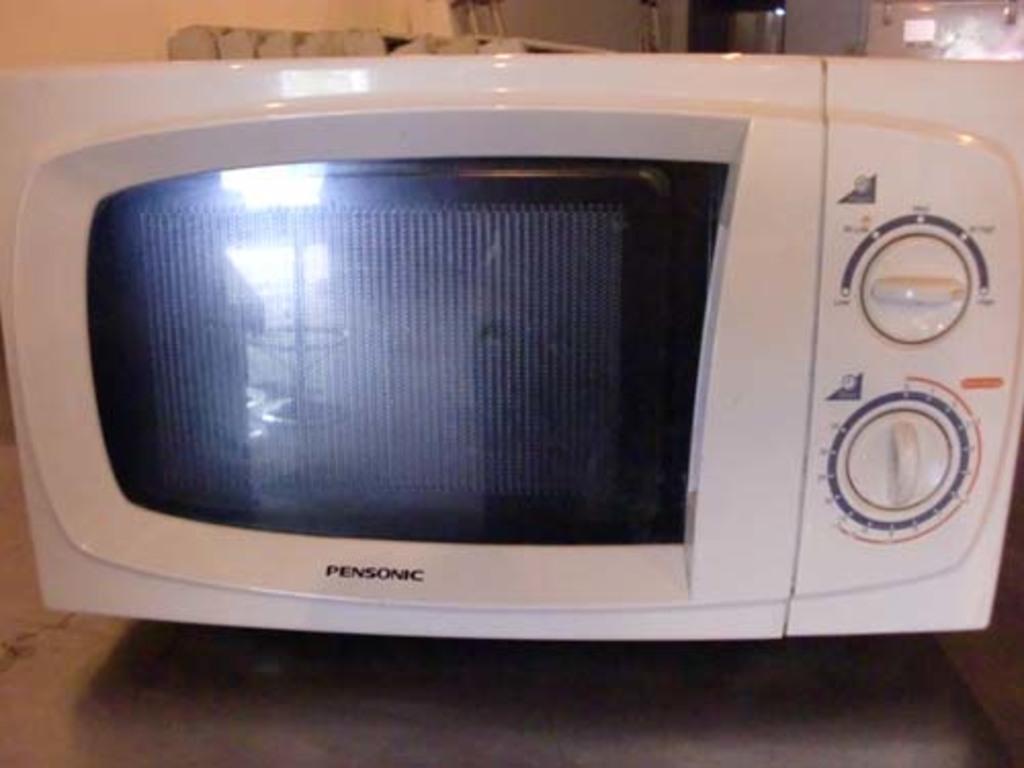What brand is this microwave?
Offer a terse response. Pensonic. 